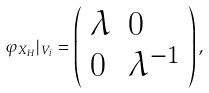<formula> <loc_0><loc_0><loc_500><loc_500>\varphi _ { X _ { H } } | _ { V _ { i } } = \left ( \begin{array} { l l } \lambda & 0 \\ 0 & \lambda ^ { - 1 } \end{array} \right ) ,</formula> 